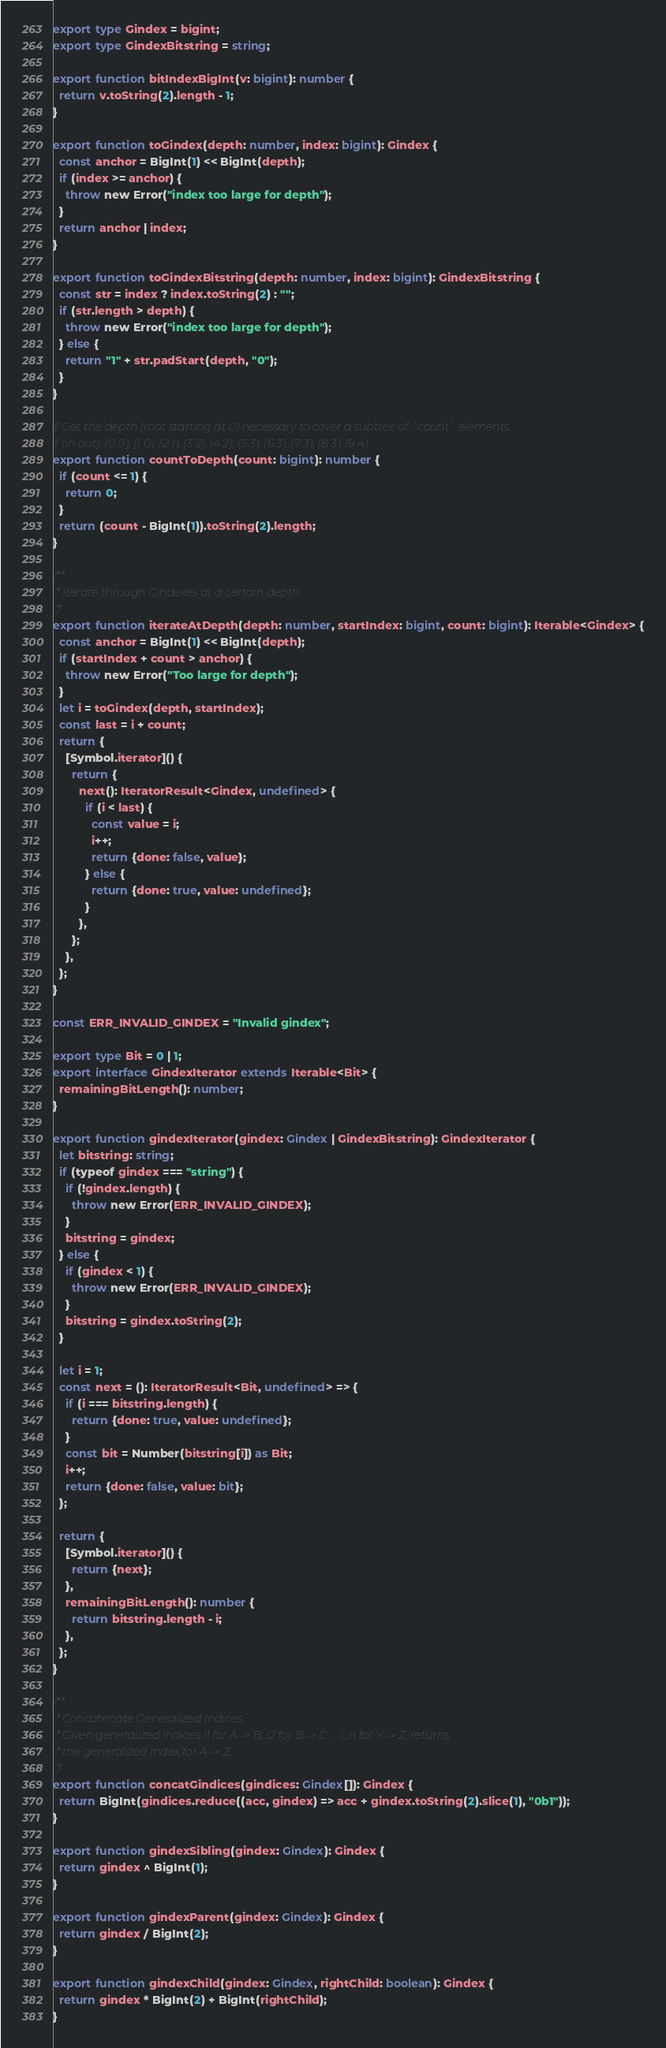Convert code to text. <code><loc_0><loc_0><loc_500><loc_500><_TypeScript_>export type Gindex = bigint;
export type GindexBitstring = string;

export function bitIndexBigInt(v: bigint): number {
  return v.toString(2).length - 1;
}

export function toGindex(depth: number, index: bigint): Gindex {
  const anchor = BigInt(1) << BigInt(depth);
  if (index >= anchor) {
    throw new Error("index too large for depth");
  }
  return anchor | index;
}

export function toGindexBitstring(depth: number, index: bigint): GindexBitstring {
  const str = index ? index.toString(2) : "";
  if (str.length > depth) {
    throw new Error("index too large for depth");
  } else {
    return "1" + str.padStart(depth, "0");
  }
}

// Get the depth (root starting at 0) necessary to cover a subtree of `count` elements.
// (in out): (0 0), (1 0), (2 1), (3 2), (4 2), (5 3), (6 3), (7 3), (8 3), (9 4)
export function countToDepth(count: bigint): number {
  if (count <= 1) {
    return 0;
  }
  return (count - BigInt(1)).toString(2).length;
}

/**
 * Iterate through Gindexes at a certain depth
 */
export function iterateAtDepth(depth: number, startIndex: bigint, count: bigint): Iterable<Gindex> {
  const anchor = BigInt(1) << BigInt(depth);
  if (startIndex + count > anchor) {
    throw new Error("Too large for depth");
  }
  let i = toGindex(depth, startIndex);
  const last = i + count;
  return {
    [Symbol.iterator]() {
      return {
        next(): IteratorResult<Gindex, undefined> {
          if (i < last) {
            const value = i;
            i++;
            return {done: false, value};
          } else {
            return {done: true, value: undefined};
          }
        },
      };
    },
  };
}

const ERR_INVALID_GINDEX = "Invalid gindex";

export type Bit = 0 | 1;
export interface GindexIterator extends Iterable<Bit> {
  remainingBitLength(): number;
}

export function gindexIterator(gindex: Gindex | GindexBitstring): GindexIterator {
  let bitstring: string;
  if (typeof gindex === "string") {
    if (!gindex.length) {
      throw new Error(ERR_INVALID_GINDEX);
    }
    bitstring = gindex;
  } else {
    if (gindex < 1) {
      throw new Error(ERR_INVALID_GINDEX);
    }
    bitstring = gindex.toString(2);
  }

  let i = 1;
  const next = (): IteratorResult<Bit, undefined> => {
    if (i === bitstring.length) {
      return {done: true, value: undefined};
    }
    const bit = Number(bitstring[i]) as Bit;
    i++;
    return {done: false, value: bit};
  };

  return {
    [Symbol.iterator]() {
      return {next};
    },
    remainingBitLength(): number {
      return bitstring.length - i;
    },
  };
}

/**
 * Concatenate Generalized Indices
 * Given generalized indices i1 for A -> B, i2 for B -> C .... i_n for Y -> Z, returns
 * the generalized index for A -> Z.
 */
export function concatGindices(gindices: Gindex[]): Gindex {
  return BigInt(gindices.reduce((acc, gindex) => acc + gindex.toString(2).slice(1), "0b1"));
}

export function gindexSibling(gindex: Gindex): Gindex {
  return gindex ^ BigInt(1);
}

export function gindexParent(gindex: Gindex): Gindex {
  return gindex / BigInt(2);
}

export function gindexChild(gindex: Gindex, rightChild: boolean): Gindex {
  return gindex * BigInt(2) + BigInt(rightChild);
}
</code> 